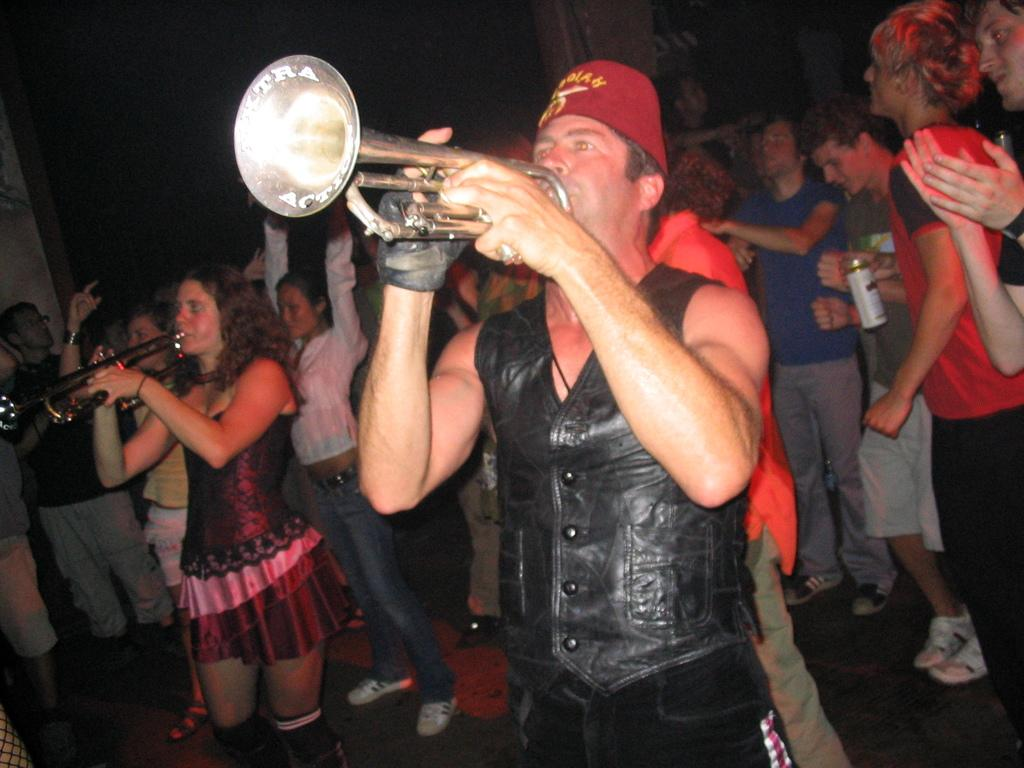How many people are in the main focus of the image? There are two persons standing in the center of the image. What are the two persons doing in the image? The two persons are playing trumpets. What can be seen in the background of the image? There is a wall and a group of people in the background of the image. What are the people in the background holding? The group of people are holding objects. What type of vegetable is being used as an eye patch by one of the trumpet players in the image? There is no vegetable or eye patch present in the image; the two persons are playing trumpets without any additional accessories. 